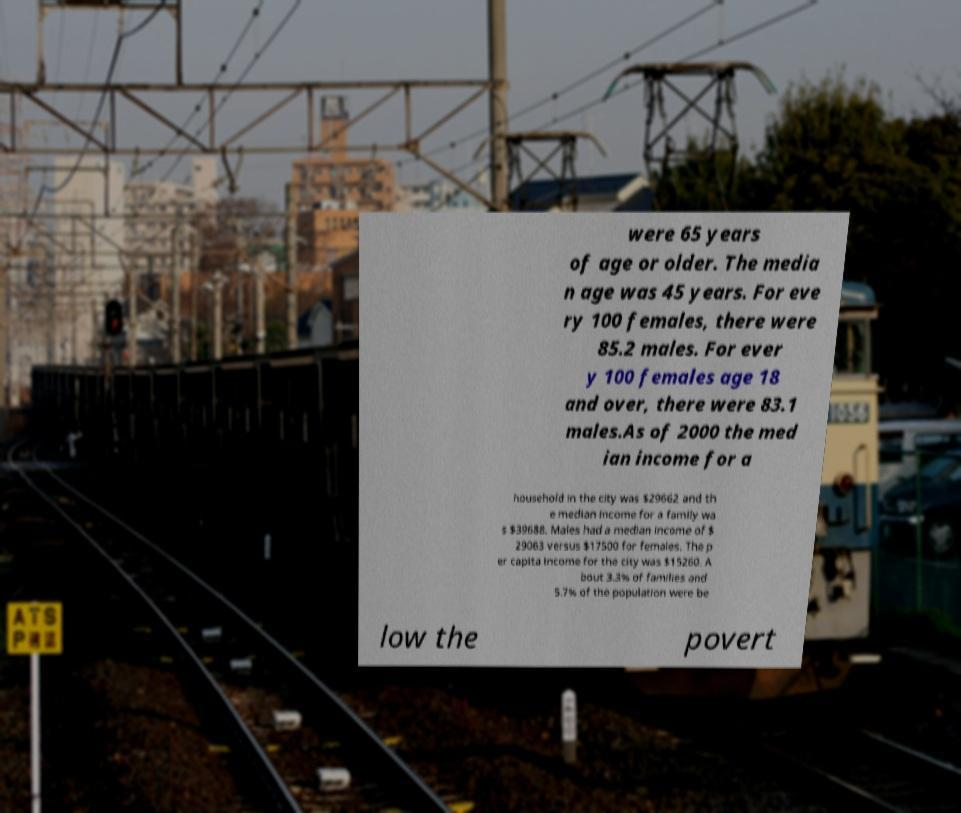Could you extract and type out the text from this image? were 65 years of age or older. The media n age was 45 years. For eve ry 100 females, there were 85.2 males. For ever y 100 females age 18 and over, there were 83.1 males.As of 2000 the med ian income for a household in the city was $29662 and th e median income for a family wa s $39688. Males had a median income of $ 29063 versus $17500 for females. The p er capita income for the city was $15260. A bout 3.3% of families and 5.7% of the population were be low the povert 